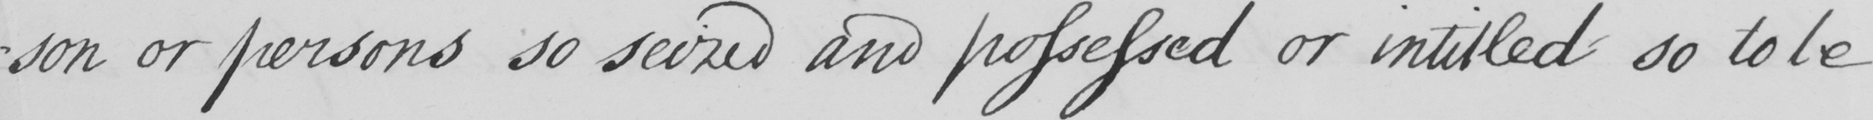Can you read and transcribe this handwriting? -son or persons so seized and possessed or intitled so to be 